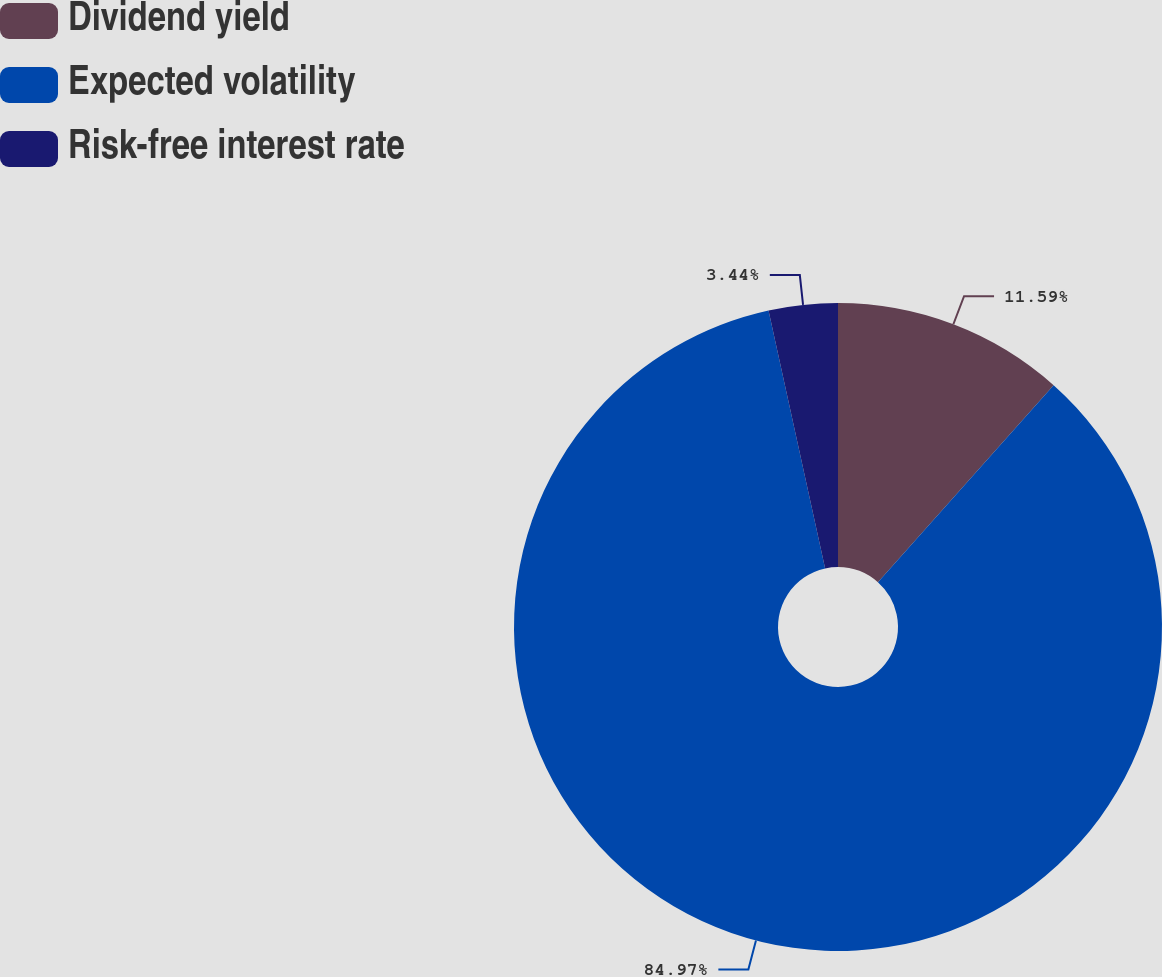Convert chart. <chart><loc_0><loc_0><loc_500><loc_500><pie_chart><fcel>Dividend yield<fcel>Expected volatility<fcel>Risk-free interest rate<nl><fcel>11.59%<fcel>84.98%<fcel>3.44%<nl></chart> 